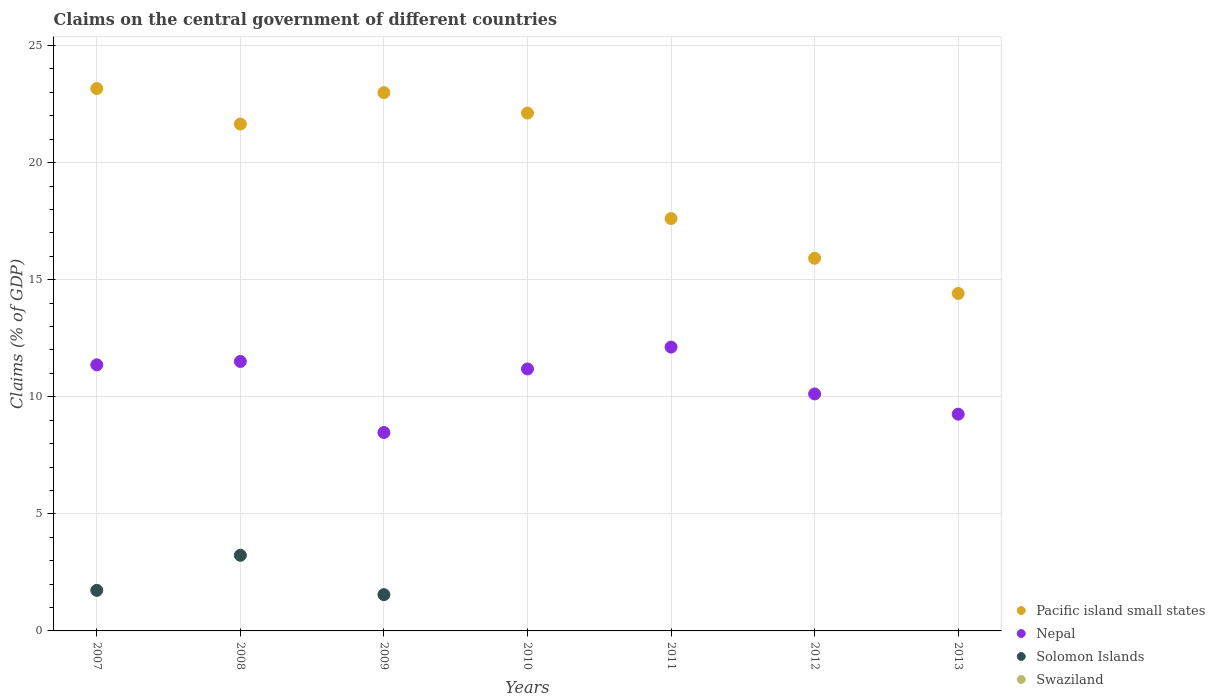Is the number of dotlines equal to the number of legend labels?
Offer a terse response. No. Across all years, what is the maximum percentage of GDP claimed on the central government in Nepal?
Keep it short and to the point. 12.12. In which year was the percentage of GDP claimed on the central government in Solomon Islands maximum?
Provide a succinct answer. 2008. What is the total percentage of GDP claimed on the central government in Solomon Islands in the graph?
Keep it short and to the point. 6.51. What is the difference between the percentage of GDP claimed on the central government in Nepal in 2007 and that in 2009?
Your answer should be compact. 2.89. What is the difference between the percentage of GDP claimed on the central government in Swaziland in 2008 and the percentage of GDP claimed on the central government in Pacific island small states in 2012?
Offer a very short reply. -15.92. What is the average percentage of GDP claimed on the central government in Pacific island small states per year?
Offer a very short reply. 19.69. In the year 2007, what is the difference between the percentage of GDP claimed on the central government in Nepal and percentage of GDP claimed on the central government in Pacific island small states?
Provide a short and direct response. -11.8. In how many years, is the percentage of GDP claimed on the central government in Nepal greater than 17 %?
Keep it short and to the point. 0. What is the ratio of the percentage of GDP claimed on the central government in Nepal in 2010 to that in 2011?
Give a very brief answer. 0.92. Is the difference between the percentage of GDP claimed on the central government in Nepal in 2007 and 2011 greater than the difference between the percentage of GDP claimed on the central government in Pacific island small states in 2007 and 2011?
Give a very brief answer. No. What is the difference between the highest and the second highest percentage of GDP claimed on the central government in Solomon Islands?
Keep it short and to the point. 1.5. What is the difference between the highest and the lowest percentage of GDP claimed on the central government in Nepal?
Keep it short and to the point. 3.65. Is it the case that in every year, the sum of the percentage of GDP claimed on the central government in Swaziland and percentage of GDP claimed on the central government in Pacific island small states  is greater than the percentage of GDP claimed on the central government in Solomon Islands?
Make the answer very short. Yes. Does the percentage of GDP claimed on the central government in Solomon Islands monotonically increase over the years?
Your answer should be very brief. No. How many dotlines are there?
Give a very brief answer. 3. How many years are there in the graph?
Provide a short and direct response. 7. Does the graph contain any zero values?
Provide a short and direct response. Yes. How are the legend labels stacked?
Offer a terse response. Vertical. What is the title of the graph?
Your answer should be very brief. Claims on the central government of different countries. What is the label or title of the Y-axis?
Keep it short and to the point. Claims (% of GDP). What is the Claims (% of GDP) of Pacific island small states in 2007?
Your answer should be very brief. 23.16. What is the Claims (% of GDP) of Nepal in 2007?
Offer a terse response. 11.36. What is the Claims (% of GDP) of Solomon Islands in 2007?
Make the answer very short. 1.73. What is the Claims (% of GDP) of Swaziland in 2007?
Ensure brevity in your answer.  0. What is the Claims (% of GDP) of Pacific island small states in 2008?
Ensure brevity in your answer.  21.65. What is the Claims (% of GDP) of Nepal in 2008?
Give a very brief answer. 11.51. What is the Claims (% of GDP) in Solomon Islands in 2008?
Your response must be concise. 3.23. What is the Claims (% of GDP) of Pacific island small states in 2009?
Your answer should be very brief. 22.99. What is the Claims (% of GDP) in Nepal in 2009?
Provide a succinct answer. 8.47. What is the Claims (% of GDP) in Solomon Islands in 2009?
Your answer should be very brief. 1.55. What is the Claims (% of GDP) of Swaziland in 2009?
Offer a terse response. 0. What is the Claims (% of GDP) in Pacific island small states in 2010?
Offer a terse response. 22.12. What is the Claims (% of GDP) in Nepal in 2010?
Your answer should be compact. 11.19. What is the Claims (% of GDP) in Solomon Islands in 2010?
Your response must be concise. 0. What is the Claims (% of GDP) of Swaziland in 2010?
Your response must be concise. 0. What is the Claims (% of GDP) of Pacific island small states in 2011?
Provide a short and direct response. 17.61. What is the Claims (% of GDP) in Nepal in 2011?
Offer a terse response. 12.12. What is the Claims (% of GDP) of Solomon Islands in 2011?
Offer a terse response. 0. What is the Claims (% of GDP) in Swaziland in 2011?
Your answer should be compact. 0. What is the Claims (% of GDP) in Pacific island small states in 2012?
Offer a terse response. 15.92. What is the Claims (% of GDP) in Nepal in 2012?
Provide a short and direct response. 10.12. What is the Claims (% of GDP) of Swaziland in 2012?
Your answer should be compact. 0. What is the Claims (% of GDP) of Pacific island small states in 2013?
Offer a terse response. 14.41. What is the Claims (% of GDP) in Nepal in 2013?
Your response must be concise. 9.26. What is the Claims (% of GDP) in Solomon Islands in 2013?
Make the answer very short. 0. What is the Claims (% of GDP) of Swaziland in 2013?
Give a very brief answer. 0. Across all years, what is the maximum Claims (% of GDP) of Pacific island small states?
Provide a short and direct response. 23.16. Across all years, what is the maximum Claims (% of GDP) of Nepal?
Your answer should be very brief. 12.12. Across all years, what is the maximum Claims (% of GDP) in Solomon Islands?
Give a very brief answer. 3.23. Across all years, what is the minimum Claims (% of GDP) of Pacific island small states?
Ensure brevity in your answer.  14.41. Across all years, what is the minimum Claims (% of GDP) of Nepal?
Provide a succinct answer. 8.47. What is the total Claims (% of GDP) in Pacific island small states in the graph?
Ensure brevity in your answer.  137.86. What is the total Claims (% of GDP) in Nepal in the graph?
Ensure brevity in your answer.  74.04. What is the total Claims (% of GDP) of Solomon Islands in the graph?
Make the answer very short. 6.51. What is the total Claims (% of GDP) in Swaziland in the graph?
Provide a short and direct response. 0. What is the difference between the Claims (% of GDP) in Pacific island small states in 2007 and that in 2008?
Your answer should be very brief. 1.52. What is the difference between the Claims (% of GDP) of Nepal in 2007 and that in 2008?
Give a very brief answer. -0.14. What is the difference between the Claims (% of GDP) in Solomon Islands in 2007 and that in 2008?
Give a very brief answer. -1.5. What is the difference between the Claims (% of GDP) of Pacific island small states in 2007 and that in 2009?
Offer a very short reply. 0.17. What is the difference between the Claims (% of GDP) of Nepal in 2007 and that in 2009?
Make the answer very short. 2.89. What is the difference between the Claims (% of GDP) of Solomon Islands in 2007 and that in 2009?
Offer a very short reply. 0.18. What is the difference between the Claims (% of GDP) of Pacific island small states in 2007 and that in 2010?
Keep it short and to the point. 1.05. What is the difference between the Claims (% of GDP) in Nepal in 2007 and that in 2010?
Offer a terse response. 0.18. What is the difference between the Claims (% of GDP) of Pacific island small states in 2007 and that in 2011?
Provide a short and direct response. 5.55. What is the difference between the Claims (% of GDP) in Nepal in 2007 and that in 2011?
Provide a short and direct response. -0.76. What is the difference between the Claims (% of GDP) in Pacific island small states in 2007 and that in 2012?
Ensure brevity in your answer.  7.25. What is the difference between the Claims (% of GDP) in Nepal in 2007 and that in 2012?
Offer a very short reply. 1.24. What is the difference between the Claims (% of GDP) of Pacific island small states in 2007 and that in 2013?
Provide a succinct answer. 8.75. What is the difference between the Claims (% of GDP) in Nepal in 2007 and that in 2013?
Offer a very short reply. 2.11. What is the difference between the Claims (% of GDP) in Pacific island small states in 2008 and that in 2009?
Make the answer very short. -1.34. What is the difference between the Claims (% of GDP) in Nepal in 2008 and that in 2009?
Your response must be concise. 3.03. What is the difference between the Claims (% of GDP) of Solomon Islands in 2008 and that in 2009?
Keep it short and to the point. 1.68. What is the difference between the Claims (% of GDP) in Pacific island small states in 2008 and that in 2010?
Make the answer very short. -0.47. What is the difference between the Claims (% of GDP) of Nepal in 2008 and that in 2010?
Offer a very short reply. 0.32. What is the difference between the Claims (% of GDP) in Pacific island small states in 2008 and that in 2011?
Offer a very short reply. 4.04. What is the difference between the Claims (% of GDP) in Nepal in 2008 and that in 2011?
Offer a very short reply. -0.61. What is the difference between the Claims (% of GDP) in Pacific island small states in 2008 and that in 2012?
Offer a terse response. 5.73. What is the difference between the Claims (% of GDP) of Nepal in 2008 and that in 2012?
Give a very brief answer. 1.39. What is the difference between the Claims (% of GDP) of Pacific island small states in 2008 and that in 2013?
Offer a terse response. 7.24. What is the difference between the Claims (% of GDP) of Nepal in 2008 and that in 2013?
Your answer should be compact. 2.25. What is the difference between the Claims (% of GDP) of Pacific island small states in 2009 and that in 2010?
Your response must be concise. 0.87. What is the difference between the Claims (% of GDP) in Nepal in 2009 and that in 2010?
Make the answer very short. -2.71. What is the difference between the Claims (% of GDP) in Pacific island small states in 2009 and that in 2011?
Offer a very short reply. 5.38. What is the difference between the Claims (% of GDP) of Nepal in 2009 and that in 2011?
Ensure brevity in your answer.  -3.65. What is the difference between the Claims (% of GDP) of Pacific island small states in 2009 and that in 2012?
Provide a succinct answer. 7.07. What is the difference between the Claims (% of GDP) of Nepal in 2009 and that in 2012?
Keep it short and to the point. -1.65. What is the difference between the Claims (% of GDP) in Pacific island small states in 2009 and that in 2013?
Ensure brevity in your answer.  8.58. What is the difference between the Claims (% of GDP) in Nepal in 2009 and that in 2013?
Give a very brief answer. -0.78. What is the difference between the Claims (% of GDP) in Pacific island small states in 2010 and that in 2011?
Your answer should be compact. 4.5. What is the difference between the Claims (% of GDP) of Nepal in 2010 and that in 2011?
Keep it short and to the point. -0.93. What is the difference between the Claims (% of GDP) in Pacific island small states in 2010 and that in 2012?
Offer a terse response. 6.2. What is the difference between the Claims (% of GDP) of Nepal in 2010 and that in 2012?
Offer a very short reply. 1.07. What is the difference between the Claims (% of GDP) of Pacific island small states in 2010 and that in 2013?
Offer a very short reply. 7.7. What is the difference between the Claims (% of GDP) in Nepal in 2010 and that in 2013?
Your answer should be compact. 1.93. What is the difference between the Claims (% of GDP) of Pacific island small states in 2011 and that in 2012?
Ensure brevity in your answer.  1.7. What is the difference between the Claims (% of GDP) of Nepal in 2011 and that in 2012?
Make the answer very short. 2. What is the difference between the Claims (% of GDP) in Pacific island small states in 2011 and that in 2013?
Your response must be concise. 3.2. What is the difference between the Claims (% of GDP) in Nepal in 2011 and that in 2013?
Offer a very short reply. 2.87. What is the difference between the Claims (% of GDP) of Pacific island small states in 2012 and that in 2013?
Keep it short and to the point. 1.5. What is the difference between the Claims (% of GDP) in Nepal in 2012 and that in 2013?
Ensure brevity in your answer.  0.86. What is the difference between the Claims (% of GDP) in Pacific island small states in 2007 and the Claims (% of GDP) in Nepal in 2008?
Provide a short and direct response. 11.65. What is the difference between the Claims (% of GDP) of Pacific island small states in 2007 and the Claims (% of GDP) of Solomon Islands in 2008?
Give a very brief answer. 19.93. What is the difference between the Claims (% of GDP) of Nepal in 2007 and the Claims (% of GDP) of Solomon Islands in 2008?
Provide a succinct answer. 8.13. What is the difference between the Claims (% of GDP) in Pacific island small states in 2007 and the Claims (% of GDP) in Nepal in 2009?
Your response must be concise. 14.69. What is the difference between the Claims (% of GDP) of Pacific island small states in 2007 and the Claims (% of GDP) of Solomon Islands in 2009?
Ensure brevity in your answer.  21.61. What is the difference between the Claims (% of GDP) in Nepal in 2007 and the Claims (% of GDP) in Solomon Islands in 2009?
Your answer should be compact. 9.81. What is the difference between the Claims (% of GDP) in Pacific island small states in 2007 and the Claims (% of GDP) in Nepal in 2010?
Your response must be concise. 11.98. What is the difference between the Claims (% of GDP) in Pacific island small states in 2007 and the Claims (% of GDP) in Nepal in 2011?
Give a very brief answer. 11.04. What is the difference between the Claims (% of GDP) of Pacific island small states in 2007 and the Claims (% of GDP) of Nepal in 2012?
Give a very brief answer. 13.04. What is the difference between the Claims (% of GDP) of Pacific island small states in 2007 and the Claims (% of GDP) of Nepal in 2013?
Offer a very short reply. 13.91. What is the difference between the Claims (% of GDP) in Pacific island small states in 2008 and the Claims (% of GDP) in Nepal in 2009?
Ensure brevity in your answer.  13.17. What is the difference between the Claims (% of GDP) in Pacific island small states in 2008 and the Claims (% of GDP) in Solomon Islands in 2009?
Your answer should be compact. 20.1. What is the difference between the Claims (% of GDP) in Nepal in 2008 and the Claims (% of GDP) in Solomon Islands in 2009?
Provide a succinct answer. 9.96. What is the difference between the Claims (% of GDP) of Pacific island small states in 2008 and the Claims (% of GDP) of Nepal in 2010?
Offer a terse response. 10.46. What is the difference between the Claims (% of GDP) of Pacific island small states in 2008 and the Claims (% of GDP) of Nepal in 2011?
Provide a short and direct response. 9.53. What is the difference between the Claims (% of GDP) of Pacific island small states in 2008 and the Claims (% of GDP) of Nepal in 2012?
Offer a very short reply. 11.53. What is the difference between the Claims (% of GDP) of Pacific island small states in 2008 and the Claims (% of GDP) of Nepal in 2013?
Offer a terse response. 12.39. What is the difference between the Claims (% of GDP) of Pacific island small states in 2009 and the Claims (% of GDP) of Nepal in 2010?
Give a very brief answer. 11.8. What is the difference between the Claims (% of GDP) of Pacific island small states in 2009 and the Claims (% of GDP) of Nepal in 2011?
Give a very brief answer. 10.87. What is the difference between the Claims (% of GDP) in Pacific island small states in 2009 and the Claims (% of GDP) in Nepal in 2012?
Provide a short and direct response. 12.87. What is the difference between the Claims (% of GDP) of Pacific island small states in 2009 and the Claims (% of GDP) of Nepal in 2013?
Your answer should be compact. 13.73. What is the difference between the Claims (% of GDP) of Pacific island small states in 2010 and the Claims (% of GDP) of Nepal in 2011?
Your answer should be compact. 10. What is the difference between the Claims (% of GDP) in Pacific island small states in 2010 and the Claims (% of GDP) in Nepal in 2012?
Offer a terse response. 12. What is the difference between the Claims (% of GDP) in Pacific island small states in 2010 and the Claims (% of GDP) in Nepal in 2013?
Ensure brevity in your answer.  12.86. What is the difference between the Claims (% of GDP) of Pacific island small states in 2011 and the Claims (% of GDP) of Nepal in 2012?
Provide a succinct answer. 7.49. What is the difference between the Claims (% of GDP) in Pacific island small states in 2011 and the Claims (% of GDP) in Nepal in 2013?
Provide a succinct answer. 8.36. What is the difference between the Claims (% of GDP) of Pacific island small states in 2012 and the Claims (% of GDP) of Nepal in 2013?
Ensure brevity in your answer.  6.66. What is the average Claims (% of GDP) of Pacific island small states per year?
Make the answer very short. 19.69. What is the average Claims (% of GDP) of Nepal per year?
Offer a terse response. 10.58. What is the average Claims (% of GDP) of Solomon Islands per year?
Make the answer very short. 0.93. In the year 2007, what is the difference between the Claims (% of GDP) in Pacific island small states and Claims (% of GDP) in Nepal?
Your answer should be very brief. 11.8. In the year 2007, what is the difference between the Claims (% of GDP) in Pacific island small states and Claims (% of GDP) in Solomon Islands?
Offer a terse response. 21.43. In the year 2007, what is the difference between the Claims (% of GDP) in Nepal and Claims (% of GDP) in Solomon Islands?
Provide a succinct answer. 9.63. In the year 2008, what is the difference between the Claims (% of GDP) of Pacific island small states and Claims (% of GDP) of Nepal?
Keep it short and to the point. 10.14. In the year 2008, what is the difference between the Claims (% of GDP) of Pacific island small states and Claims (% of GDP) of Solomon Islands?
Ensure brevity in your answer.  18.42. In the year 2008, what is the difference between the Claims (% of GDP) of Nepal and Claims (% of GDP) of Solomon Islands?
Offer a terse response. 8.28. In the year 2009, what is the difference between the Claims (% of GDP) in Pacific island small states and Claims (% of GDP) in Nepal?
Provide a succinct answer. 14.52. In the year 2009, what is the difference between the Claims (% of GDP) of Pacific island small states and Claims (% of GDP) of Solomon Islands?
Offer a very short reply. 21.44. In the year 2009, what is the difference between the Claims (% of GDP) of Nepal and Claims (% of GDP) of Solomon Islands?
Your answer should be compact. 6.92. In the year 2010, what is the difference between the Claims (% of GDP) in Pacific island small states and Claims (% of GDP) in Nepal?
Provide a short and direct response. 10.93. In the year 2011, what is the difference between the Claims (% of GDP) in Pacific island small states and Claims (% of GDP) in Nepal?
Provide a short and direct response. 5.49. In the year 2012, what is the difference between the Claims (% of GDP) of Pacific island small states and Claims (% of GDP) of Nepal?
Provide a short and direct response. 5.79. In the year 2013, what is the difference between the Claims (% of GDP) of Pacific island small states and Claims (% of GDP) of Nepal?
Your answer should be very brief. 5.16. What is the ratio of the Claims (% of GDP) in Pacific island small states in 2007 to that in 2008?
Provide a succinct answer. 1.07. What is the ratio of the Claims (% of GDP) in Nepal in 2007 to that in 2008?
Ensure brevity in your answer.  0.99. What is the ratio of the Claims (% of GDP) in Solomon Islands in 2007 to that in 2008?
Offer a terse response. 0.54. What is the ratio of the Claims (% of GDP) of Pacific island small states in 2007 to that in 2009?
Give a very brief answer. 1.01. What is the ratio of the Claims (% of GDP) of Nepal in 2007 to that in 2009?
Make the answer very short. 1.34. What is the ratio of the Claims (% of GDP) in Solomon Islands in 2007 to that in 2009?
Offer a terse response. 1.12. What is the ratio of the Claims (% of GDP) in Pacific island small states in 2007 to that in 2010?
Your answer should be very brief. 1.05. What is the ratio of the Claims (% of GDP) in Nepal in 2007 to that in 2010?
Make the answer very short. 1.02. What is the ratio of the Claims (% of GDP) of Pacific island small states in 2007 to that in 2011?
Keep it short and to the point. 1.32. What is the ratio of the Claims (% of GDP) of Nepal in 2007 to that in 2011?
Provide a short and direct response. 0.94. What is the ratio of the Claims (% of GDP) in Pacific island small states in 2007 to that in 2012?
Keep it short and to the point. 1.46. What is the ratio of the Claims (% of GDP) in Nepal in 2007 to that in 2012?
Make the answer very short. 1.12. What is the ratio of the Claims (% of GDP) in Pacific island small states in 2007 to that in 2013?
Offer a terse response. 1.61. What is the ratio of the Claims (% of GDP) of Nepal in 2007 to that in 2013?
Offer a terse response. 1.23. What is the ratio of the Claims (% of GDP) of Pacific island small states in 2008 to that in 2009?
Make the answer very short. 0.94. What is the ratio of the Claims (% of GDP) in Nepal in 2008 to that in 2009?
Your response must be concise. 1.36. What is the ratio of the Claims (% of GDP) in Solomon Islands in 2008 to that in 2009?
Offer a very short reply. 2.08. What is the ratio of the Claims (% of GDP) of Pacific island small states in 2008 to that in 2010?
Make the answer very short. 0.98. What is the ratio of the Claims (% of GDP) of Nepal in 2008 to that in 2010?
Offer a very short reply. 1.03. What is the ratio of the Claims (% of GDP) in Pacific island small states in 2008 to that in 2011?
Ensure brevity in your answer.  1.23. What is the ratio of the Claims (% of GDP) of Nepal in 2008 to that in 2011?
Offer a very short reply. 0.95. What is the ratio of the Claims (% of GDP) of Pacific island small states in 2008 to that in 2012?
Give a very brief answer. 1.36. What is the ratio of the Claims (% of GDP) in Nepal in 2008 to that in 2012?
Offer a very short reply. 1.14. What is the ratio of the Claims (% of GDP) in Pacific island small states in 2008 to that in 2013?
Make the answer very short. 1.5. What is the ratio of the Claims (% of GDP) in Nepal in 2008 to that in 2013?
Your answer should be very brief. 1.24. What is the ratio of the Claims (% of GDP) in Pacific island small states in 2009 to that in 2010?
Keep it short and to the point. 1.04. What is the ratio of the Claims (% of GDP) in Nepal in 2009 to that in 2010?
Provide a short and direct response. 0.76. What is the ratio of the Claims (% of GDP) in Pacific island small states in 2009 to that in 2011?
Keep it short and to the point. 1.31. What is the ratio of the Claims (% of GDP) of Nepal in 2009 to that in 2011?
Keep it short and to the point. 0.7. What is the ratio of the Claims (% of GDP) of Pacific island small states in 2009 to that in 2012?
Offer a very short reply. 1.44. What is the ratio of the Claims (% of GDP) of Nepal in 2009 to that in 2012?
Provide a short and direct response. 0.84. What is the ratio of the Claims (% of GDP) in Pacific island small states in 2009 to that in 2013?
Your response must be concise. 1.59. What is the ratio of the Claims (% of GDP) of Nepal in 2009 to that in 2013?
Make the answer very short. 0.92. What is the ratio of the Claims (% of GDP) of Pacific island small states in 2010 to that in 2011?
Your response must be concise. 1.26. What is the ratio of the Claims (% of GDP) of Nepal in 2010 to that in 2011?
Provide a short and direct response. 0.92. What is the ratio of the Claims (% of GDP) of Pacific island small states in 2010 to that in 2012?
Provide a succinct answer. 1.39. What is the ratio of the Claims (% of GDP) of Nepal in 2010 to that in 2012?
Make the answer very short. 1.11. What is the ratio of the Claims (% of GDP) of Pacific island small states in 2010 to that in 2013?
Ensure brevity in your answer.  1.53. What is the ratio of the Claims (% of GDP) in Nepal in 2010 to that in 2013?
Your response must be concise. 1.21. What is the ratio of the Claims (% of GDP) of Pacific island small states in 2011 to that in 2012?
Provide a succinct answer. 1.11. What is the ratio of the Claims (% of GDP) of Nepal in 2011 to that in 2012?
Your response must be concise. 1.2. What is the ratio of the Claims (% of GDP) in Pacific island small states in 2011 to that in 2013?
Give a very brief answer. 1.22. What is the ratio of the Claims (% of GDP) of Nepal in 2011 to that in 2013?
Keep it short and to the point. 1.31. What is the ratio of the Claims (% of GDP) of Pacific island small states in 2012 to that in 2013?
Make the answer very short. 1.1. What is the ratio of the Claims (% of GDP) in Nepal in 2012 to that in 2013?
Your answer should be very brief. 1.09. What is the difference between the highest and the second highest Claims (% of GDP) of Pacific island small states?
Offer a terse response. 0.17. What is the difference between the highest and the second highest Claims (% of GDP) in Nepal?
Your answer should be very brief. 0.61. What is the difference between the highest and the second highest Claims (% of GDP) of Solomon Islands?
Ensure brevity in your answer.  1.5. What is the difference between the highest and the lowest Claims (% of GDP) in Pacific island small states?
Offer a very short reply. 8.75. What is the difference between the highest and the lowest Claims (% of GDP) in Nepal?
Make the answer very short. 3.65. What is the difference between the highest and the lowest Claims (% of GDP) of Solomon Islands?
Your answer should be compact. 3.23. 